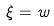<formula> <loc_0><loc_0><loc_500><loc_500>\xi = w</formula> 